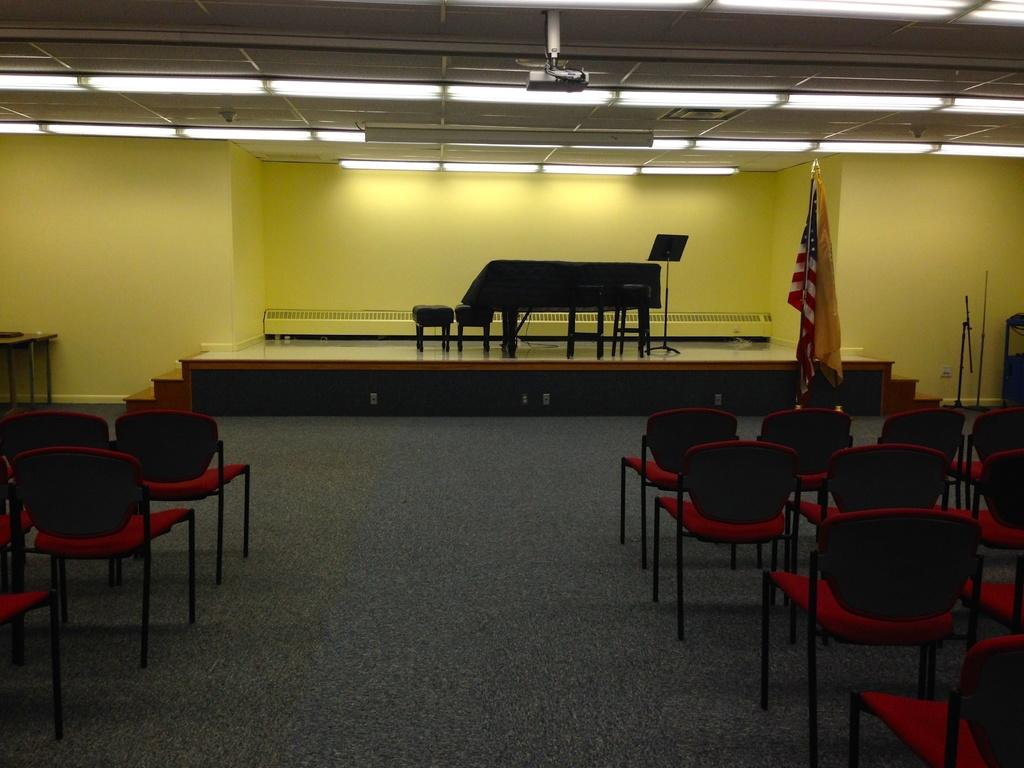What is located in the center of the image? There are empty chairs in the center of the image. What can be seen in the background of the image? There is a stage, a wall, a staircase, a stand, tables, stools, flags, and lights in the background of the image. What type of wilderness can be seen in the image? There is no wilderness present in the image; it features a stage, chairs, and various background elements. 